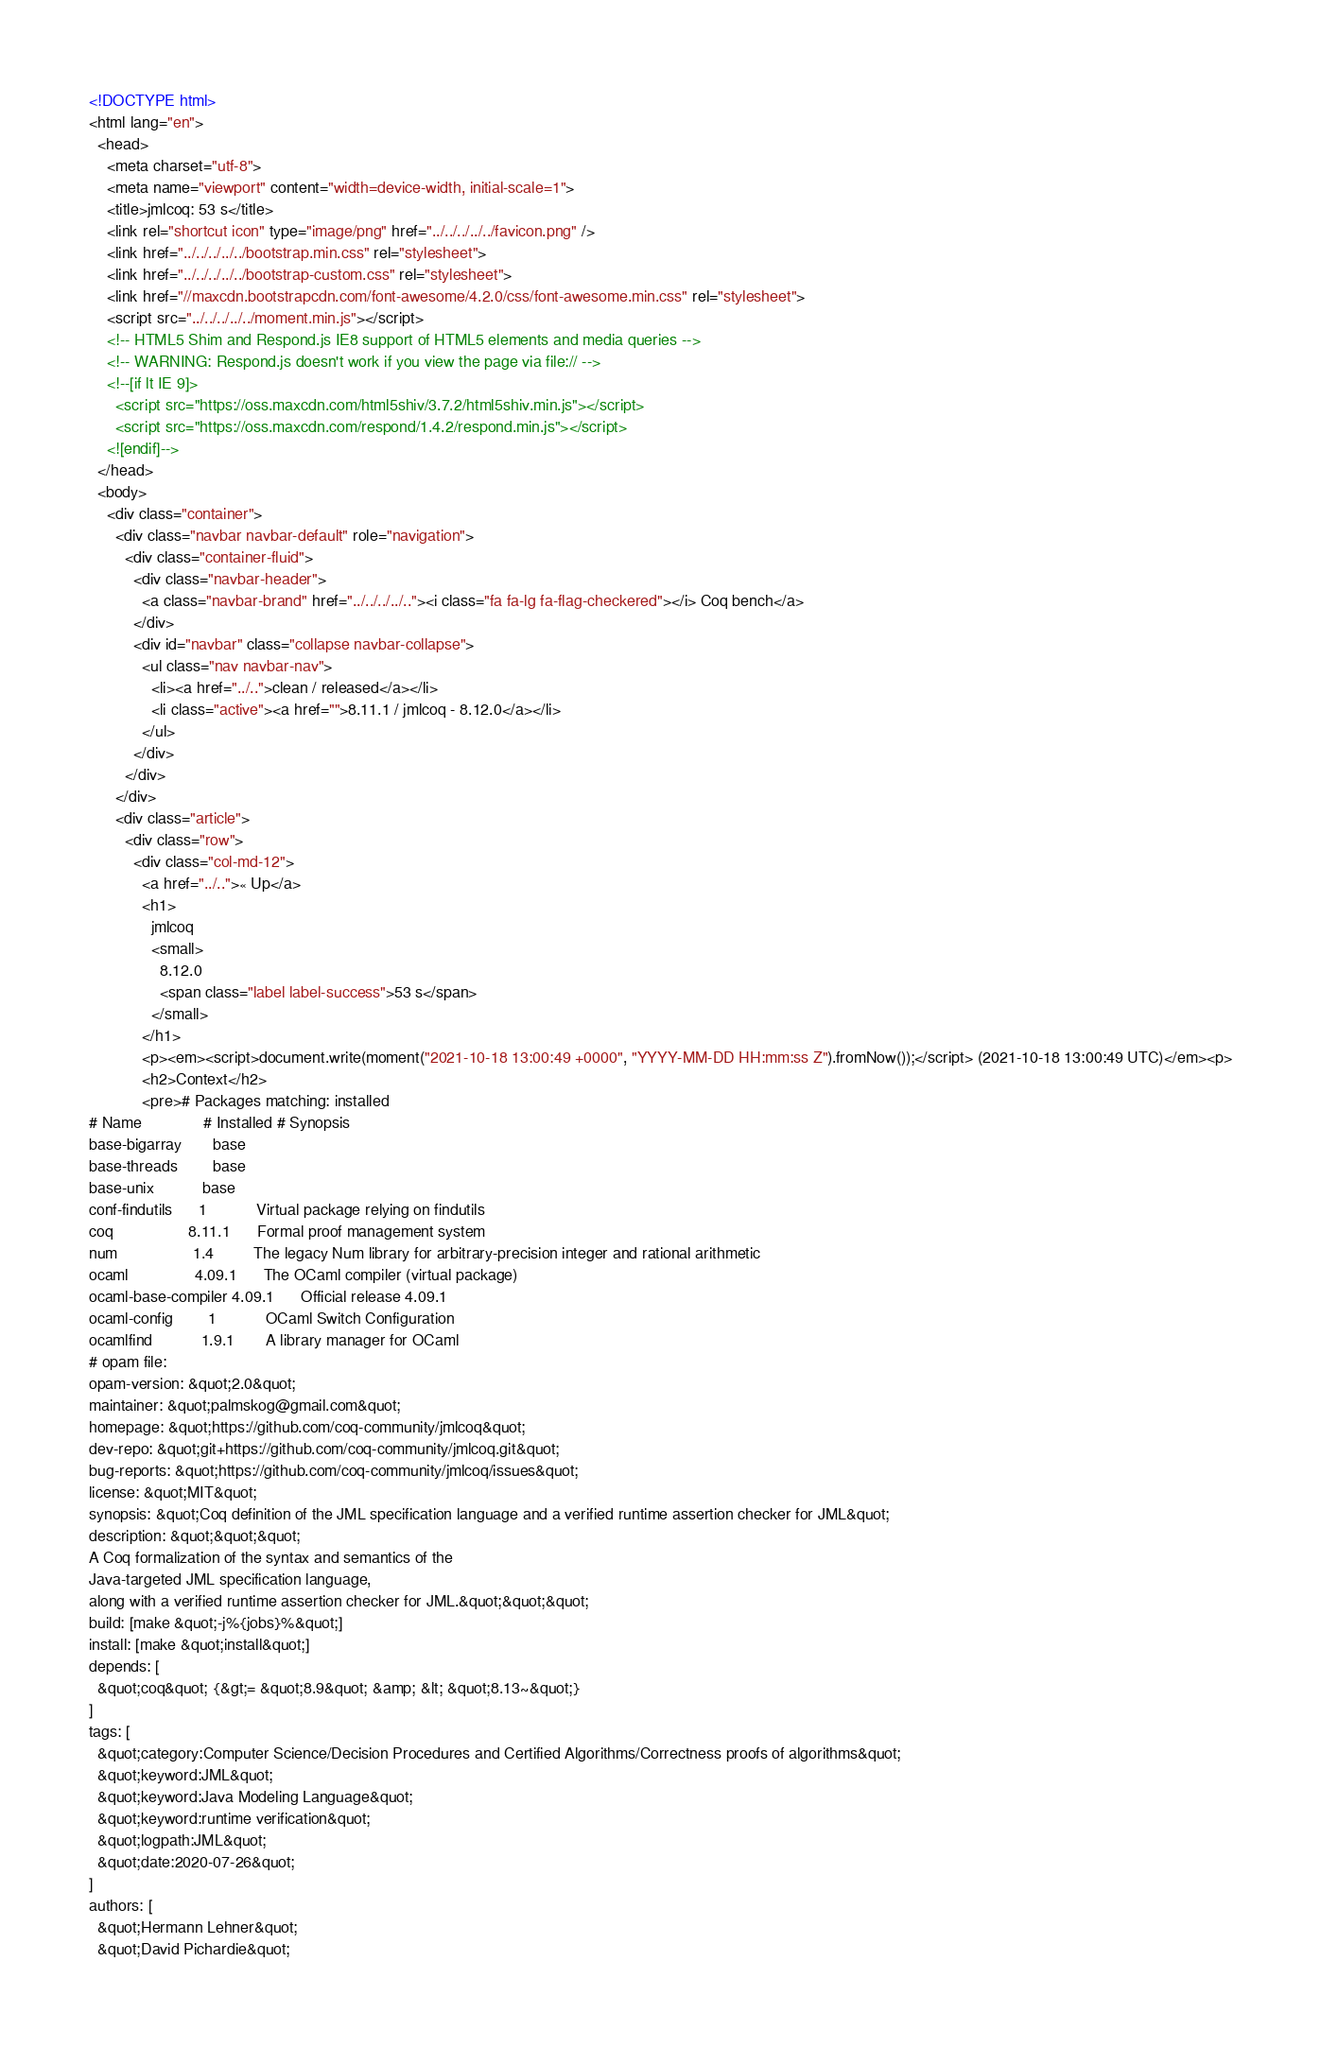Convert code to text. <code><loc_0><loc_0><loc_500><loc_500><_HTML_><!DOCTYPE html>
<html lang="en">
  <head>
    <meta charset="utf-8">
    <meta name="viewport" content="width=device-width, initial-scale=1">
    <title>jmlcoq: 53 s</title>
    <link rel="shortcut icon" type="image/png" href="../../../../../favicon.png" />
    <link href="../../../../../bootstrap.min.css" rel="stylesheet">
    <link href="../../../../../bootstrap-custom.css" rel="stylesheet">
    <link href="//maxcdn.bootstrapcdn.com/font-awesome/4.2.0/css/font-awesome.min.css" rel="stylesheet">
    <script src="../../../../../moment.min.js"></script>
    <!-- HTML5 Shim and Respond.js IE8 support of HTML5 elements and media queries -->
    <!-- WARNING: Respond.js doesn't work if you view the page via file:// -->
    <!--[if lt IE 9]>
      <script src="https://oss.maxcdn.com/html5shiv/3.7.2/html5shiv.min.js"></script>
      <script src="https://oss.maxcdn.com/respond/1.4.2/respond.min.js"></script>
    <![endif]-->
  </head>
  <body>
    <div class="container">
      <div class="navbar navbar-default" role="navigation">
        <div class="container-fluid">
          <div class="navbar-header">
            <a class="navbar-brand" href="../../../../.."><i class="fa fa-lg fa-flag-checkered"></i> Coq bench</a>
          </div>
          <div id="navbar" class="collapse navbar-collapse">
            <ul class="nav navbar-nav">
              <li><a href="../..">clean / released</a></li>
              <li class="active"><a href="">8.11.1 / jmlcoq - 8.12.0</a></li>
            </ul>
          </div>
        </div>
      </div>
      <div class="article">
        <div class="row">
          <div class="col-md-12">
            <a href="../..">« Up</a>
            <h1>
              jmlcoq
              <small>
                8.12.0
                <span class="label label-success">53 s</span>
              </small>
            </h1>
            <p><em><script>document.write(moment("2021-10-18 13:00:49 +0000", "YYYY-MM-DD HH:mm:ss Z").fromNow());</script> (2021-10-18 13:00:49 UTC)</em><p>
            <h2>Context</h2>
            <pre># Packages matching: installed
# Name              # Installed # Synopsis
base-bigarray       base
base-threads        base
base-unix           base
conf-findutils      1           Virtual package relying on findutils
coq                 8.11.1      Formal proof management system
num                 1.4         The legacy Num library for arbitrary-precision integer and rational arithmetic
ocaml               4.09.1      The OCaml compiler (virtual package)
ocaml-base-compiler 4.09.1      Official release 4.09.1
ocaml-config        1           OCaml Switch Configuration
ocamlfind           1.9.1       A library manager for OCaml
# opam file:
opam-version: &quot;2.0&quot;
maintainer: &quot;palmskog@gmail.com&quot;
homepage: &quot;https://github.com/coq-community/jmlcoq&quot;
dev-repo: &quot;git+https://github.com/coq-community/jmlcoq.git&quot;
bug-reports: &quot;https://github.com/coq-community/jmlcoq/issues&quot;
license: &quot;MIT&quot;
synopsis: &quot;Coq definition of the JML specification language and a verified runtime assertion checker for JML&quot;
description: &quot;&quot;&quot;
A Coq formalization of the syntax and semantics of the
Java-targeted JML specification language,
along with a verified runtime assertion checker for JML.&quot;&quot;&quot;
build: [make &quot;-j%{jobs}%&quot;]
install: [make &quot;install&quot;]
depends: [
  &quot;coq&quot; {&gt;= &quot;8.9&quot; &amp; &lt; &quot;8.13~&quot;}
]
tags: [
  &quot;category:Computer Science/Decision Procedures and Certified Algorithms/Correctness proofs of algorithms&quot;
  &quot;keyword:JML&quot;
  &quot;keyword:Java Modeling Language&quot;
  &quot;keyword:runtime verification&quot;
  &quot;logpath:JML&quot;
  &quot;date:2020-07-26&quot;
]
authors: [
  &quot;Hermann Lehner&quot;
  &quot;David Pichardie&quot;</code> 